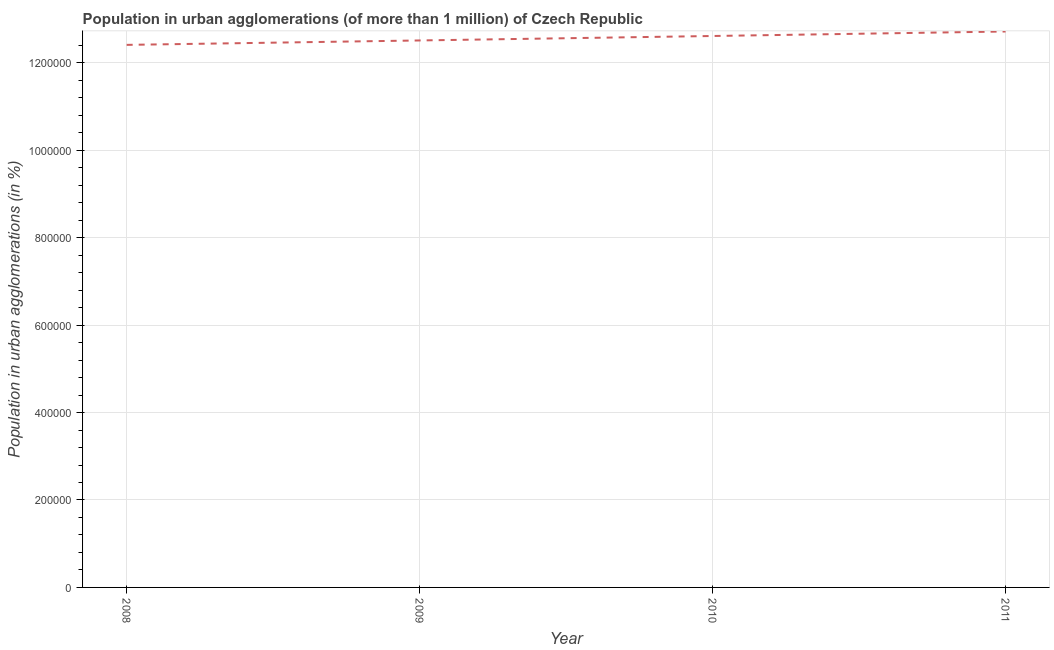What is the population in urban agglomerations in 2010?
Offer a very short reply. 1.26e+06. Across all years, what is the maximum population in urban agglomerations?
Give a very brief answer. 1.27e+06. Across all years, what is the minimum population in urban agglomerations?
Keep it short and to the point. 1.24e+06. In which year was the population in urban agglomerations maximum?
Your answer should be compact. 2011. In which year was the population in urban agglomerations minimum?
Offer a terse response. 2008. What is the sum of the population in urban agglomerations?
Provide a succinct answer. 5.02e+06. What is the difference between the population in urban agglomerations in 2008 and 2011?
Your response must be concise. -3.06e+04. What is the average population in urban agglomerations per year?
Give a very brief answer. 1.26e+06. What is the median population in urban agglomerations?
Offer a very short reply. 1.26e+06. What is the ratio of the population in urban agglomerations in 2008 to that in 2010?
Your answer should be compact. 0.98. Is the population in urban agglomerations in 2009 less than that in 2010?
Offer a very short reply. Yes. Is the difference between the population in urban agglomerations in 2010 and 2011 greater than the difference between any two years?
Offer a very short reply. No. What is the difference between the highest and the second highest population in urban agglomerations?
Provide a succinct answer. 1.03e+04. Is the sum of the population in urban agglomerations in 2008 and 2009 greater than the maximum population in urban agglomerations across all years?
Keep it short and to the point. Yes. What is the difference between the highest and the lowest population in urban agglomerations?
Offer a very short reply. 3.06e+04. In how many years, is the population in urban agglomerations greater than the average population in urban agglomerations taken over all years?
Offer a very short reply. 2. Does the population in urban agglomerations monotonically increase over the years?
Your answer should be very brief. Yes. How many years are there in the graph?
Offer a very short reply. 4. What is the difference between two consecutive major ticks on the Y-axis?
Ensure brevity in your answer.  2.00e+05. Does the graph contain grids?
Your answer should be very brief. Yes. What is the title of the graph?
Provide a succinct answer. Population in urban agglomerations (of more than 1 million) of Czech Republic. What is the label or title of the Y-axis?
Your answer should be very brief. Population in urban agglomerations (in %). What is the Population in urban agglomerations (in %) in 2008?
Make the answer very short. 1.24e+06. What is the Population in urban agglomerations (in %) of 2009?
Offer a very short reply. 1.25e+06. What is the Population in urban agglomerations (in %) in 2010?
Your answer should be very brief. 1.26e+06. What is the Population in urban agglomerations (in %) in 2011?
Your answer should be compact. 1.27e+06. What is the difference between the Population in urban agglomerations (in %) in 2008 and 2009?
Your response must be concise. -1.01e+04. What is the difference between the Population in urban agglomerations (in %) in 2008 and 2010?
Make the answer very short. -2.03e+04. What is the difference between the Population in urban agglomerations (in %) in 2008 and 2011?
Provide a succinct answer. -3.06e+04. What is the difference between the Population in urban agglomerations (in %) in 2009 and 2010?
Your answer should be compact. -1.02e+04. What is the difference between the Population in urban agglomerations (in %) in 2009 and 2011?
Provide a short and direct response. -2.05e+04. What is the difference between the Population in urban agglomerations (in %) in 2010 and 2011?
Your answer should be very brief. -1.03e+04. What is the ratio of the Population in urban agglomerations (in %) in 2008 to that in 2011?
Provide a short and direct response. 0.98. What is the ratio of the Population in urban agglomerations (in %) in 2009 to that in 2010?
Your response must be concise. 0.99. What is the ratio of the Population in urban agglomerations (in %) in 2009 to that in 2011?
Your answer should be compact. 0.98. What is the ratio of the Population in urban agglomerations (in %) in 2010 to that in 2011?
Provide a short and direct response. 0.99. 